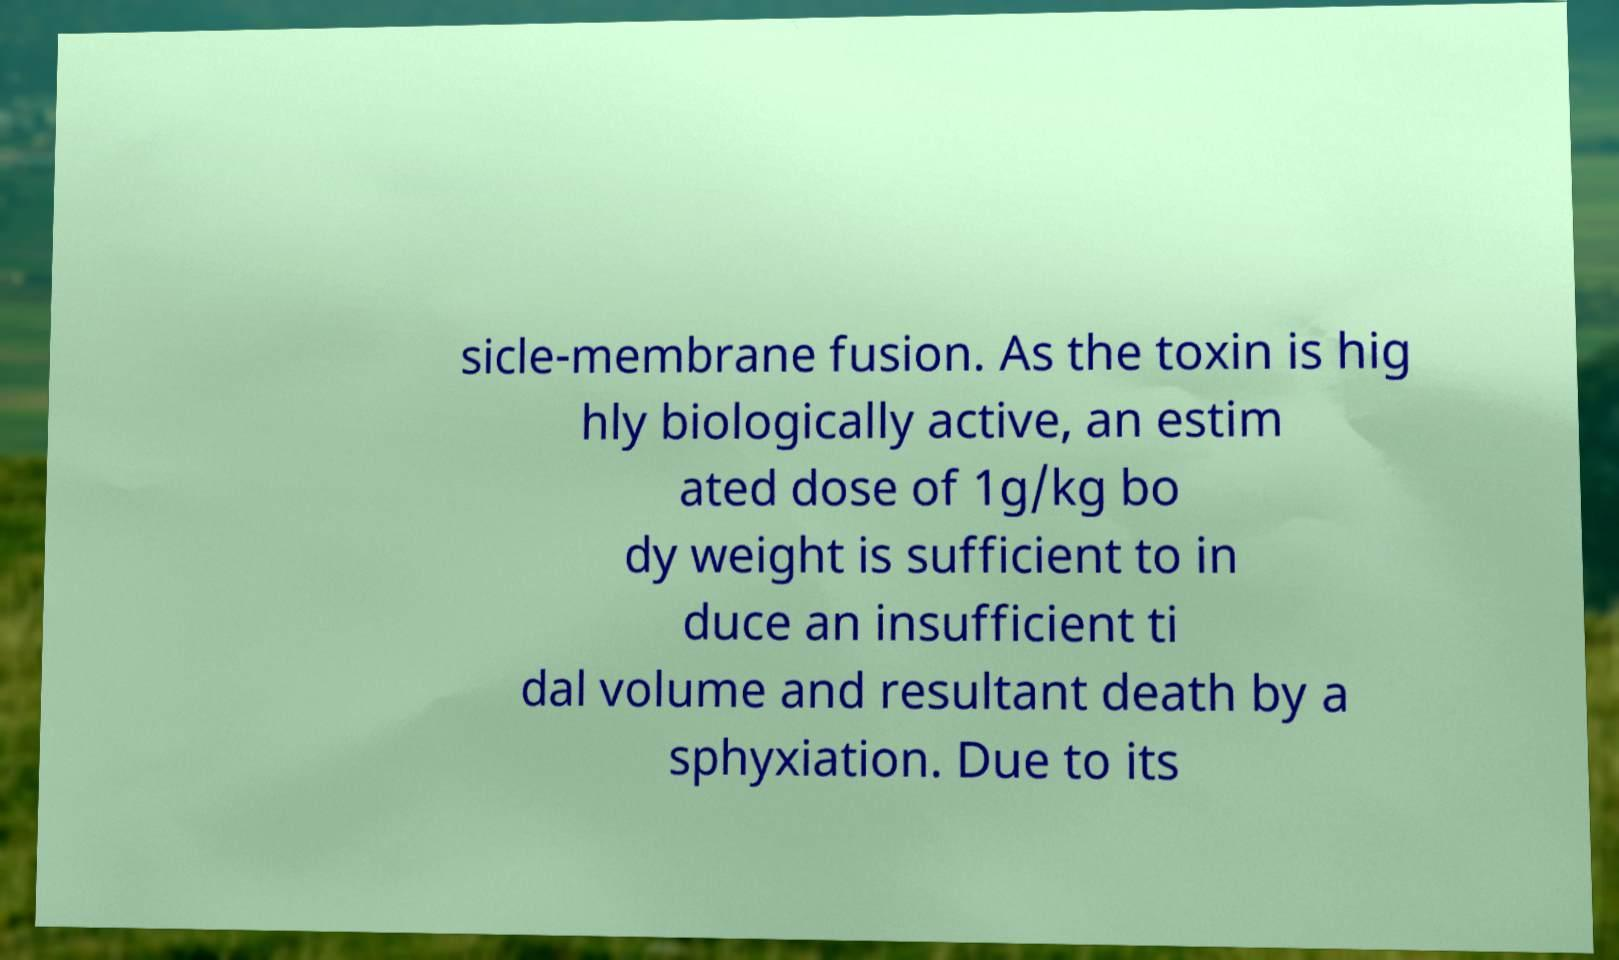Please read and relay the text visible in this image. What does it say? sicle-membrane fusion. As the toxin is hig hly biologically active, an estim ated dose of 1g/kg bo dy weight is sufficient to in duce an insufficient ti dal volume and resultant death by a sphyxiation. Due to its 